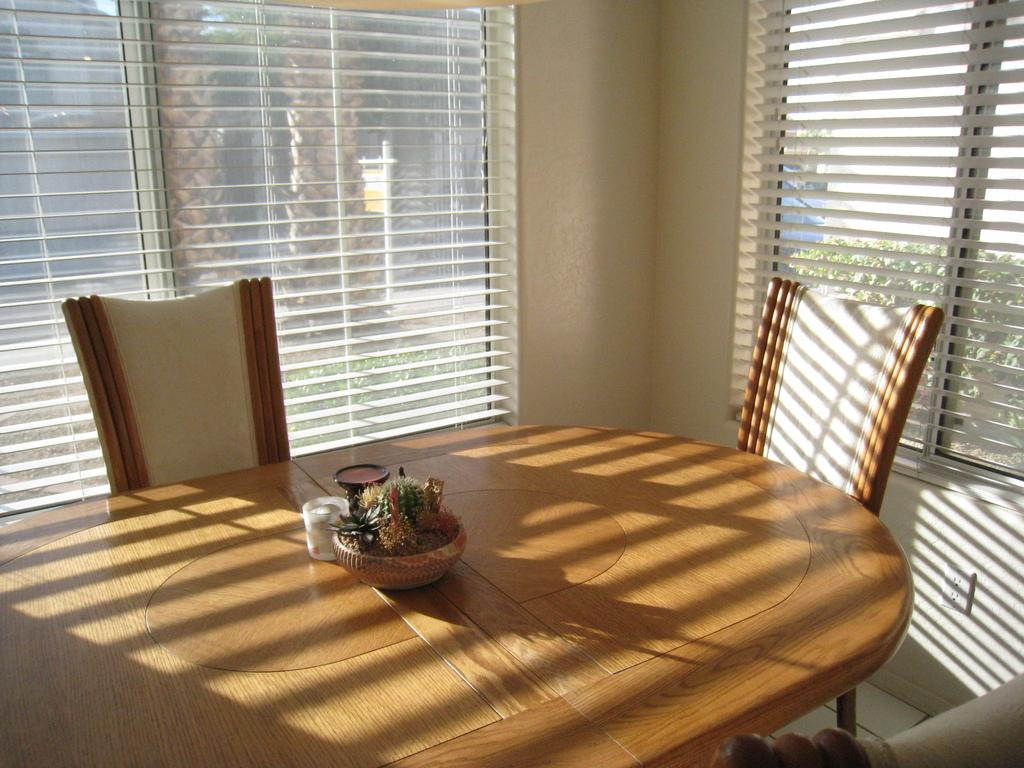What type of space is depicted in the image? The image consists of a room. What furniture is present in the room? There is a dining table in the room, and chairs are placed around the dining table. How many windows are in the room? There are windows on both the left and right sides of the room. What type of window treatment is present in the image? Window blinds are present on the windows. Who is the sister of the creator of the room in the image? There is no information about the creator of the room in the image, so it is impossible to determine who their sister might be. 